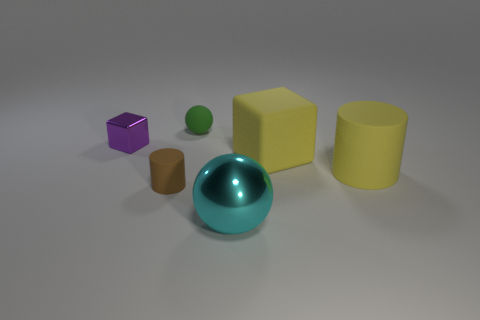What is the material of the sphere that is the same size as the yellow cylinder?
Give a very brief answer. Metal. How many other things are there of the same material as the purple thing?
Your response must be concise. 1. There is a cyan thing; what number of brown cylinders are to the left of it?
Offer a terse response. 1. How many blocks are either large red metallic objects or big cyan shiny objects?
Make the answer very short. 0. What is the size of the object that is behind the large rubber cylinder and in front of the metal cube?
Provide a short and direct response. Large. How many other things are there of the same color as the big matte cylinder?
Ensure brevity in your answer.  1. Do the small brown object and the block left of the big cyan object have the same material?
Make the answer very short. No. What number of objects are spheres to the right of the rubber sphere or large yellow rubber cylinders?
Make the answer very short. 2. There is a large thing that is both on the left side of the yellow rubber cylinder and behind the small brown cylinder; what is its shape?
Give a very brief answer. Cube. What is the size of the sphere that is made of the same material as the small brown thing?
Your answer should be compact. Small. 